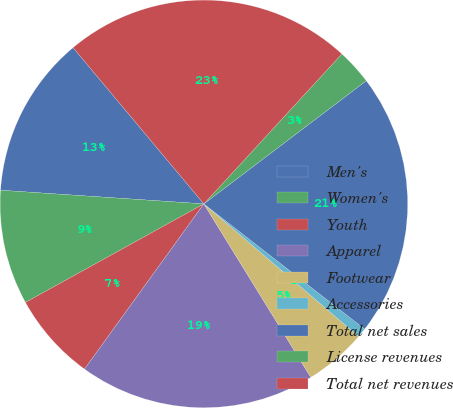Convert chart to OTSL. <chart><loc_0><loc_0><loc_500><loc_500><pie_chart><fcel>Men's<fcel>Women's<fcel>Youth<fcel>Apparel<fcel>Footwear<fcel>Accessories<fcel>Total net sales<fcel>License revenues<fcel>Total net revenues<nl><fcel>12.84%<fcel>9.1%<fcel>7.01%<fcel>18.75%<fcel>4.93%<fcel>0.75%<fcel>20.85%<fcel>2.84%<fcel>22.93%<nl></chart> 